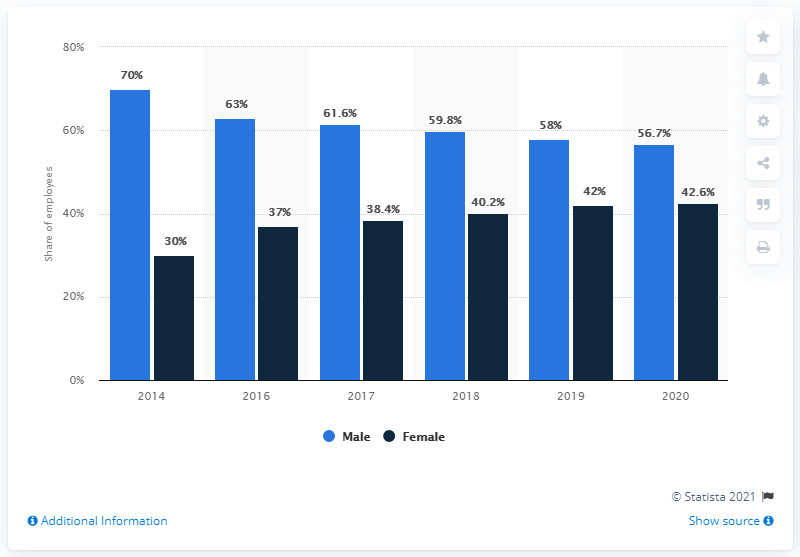Could this data be used to predict future trends in the workforce? While historical data like this can offer insights and help forecast future trends, predictions would require a more in-depth analysis including external factors like industry growth, education demographics, cultural shifts, and company-specific initiatives aimed at diversity and inclusion. 